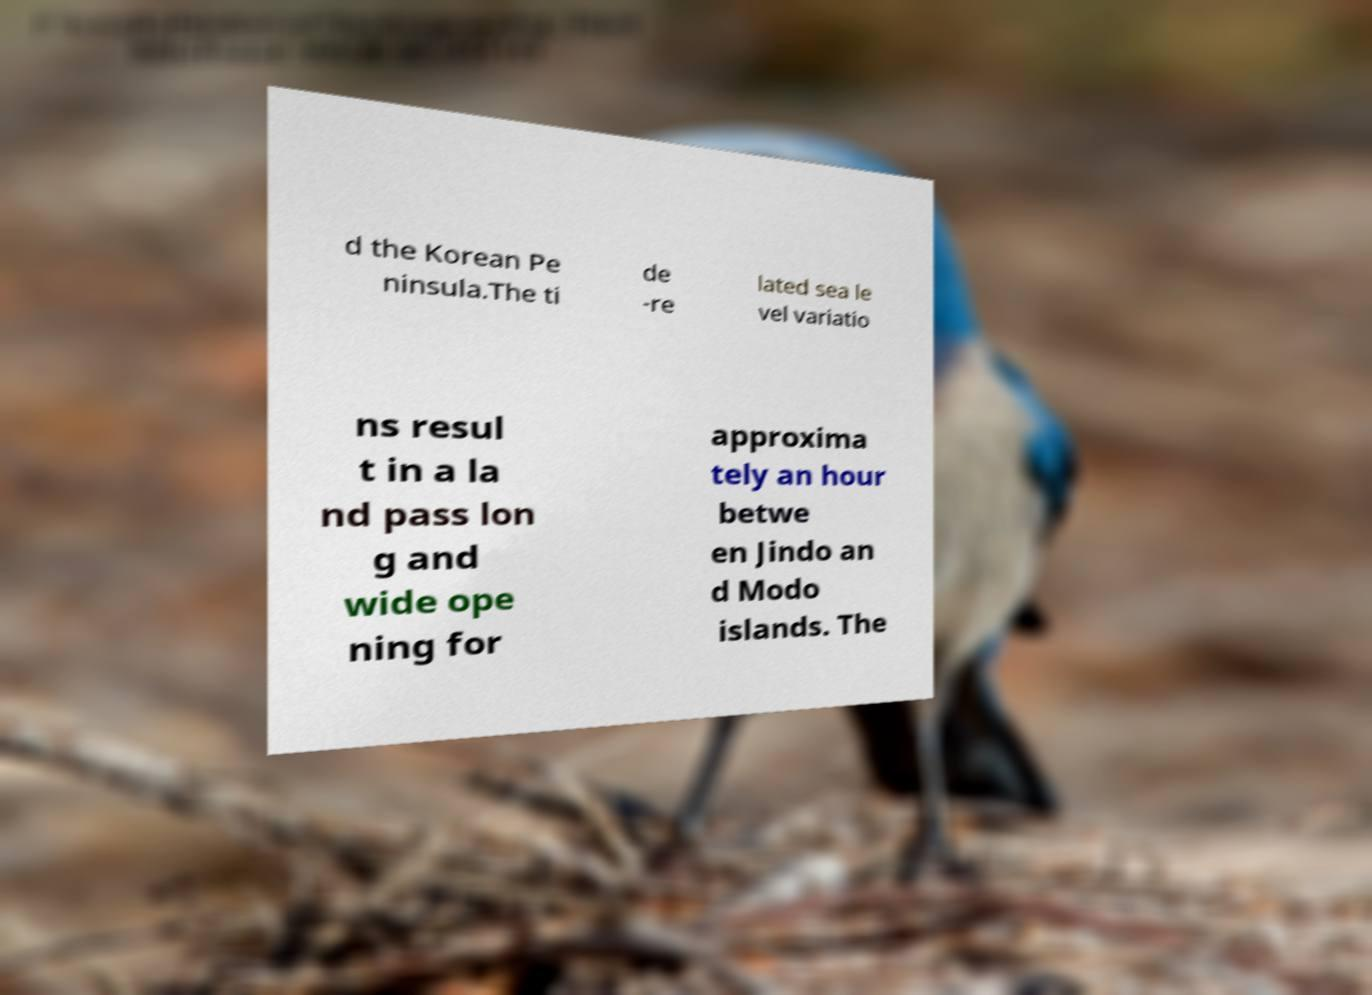There's text embedded in this image that I need extracted. Can you transcribe it verbatim? d the Korean Pe ninsula.The ti de -re lated sea le vel variatio ns resul t in a la nd pass lon g and wide ope ning for approxima tely an hour betwe en Jindo an d Modo islands. The 